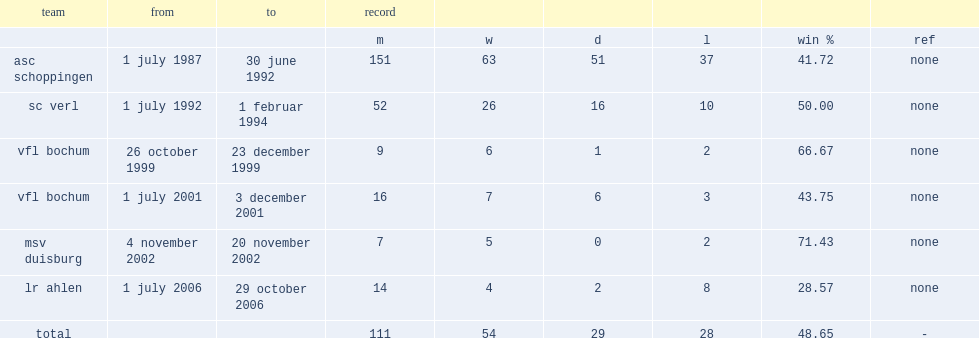From 1 july 1992 to 1 february 1994, which team did bernard dietz play for? Sc verl. 